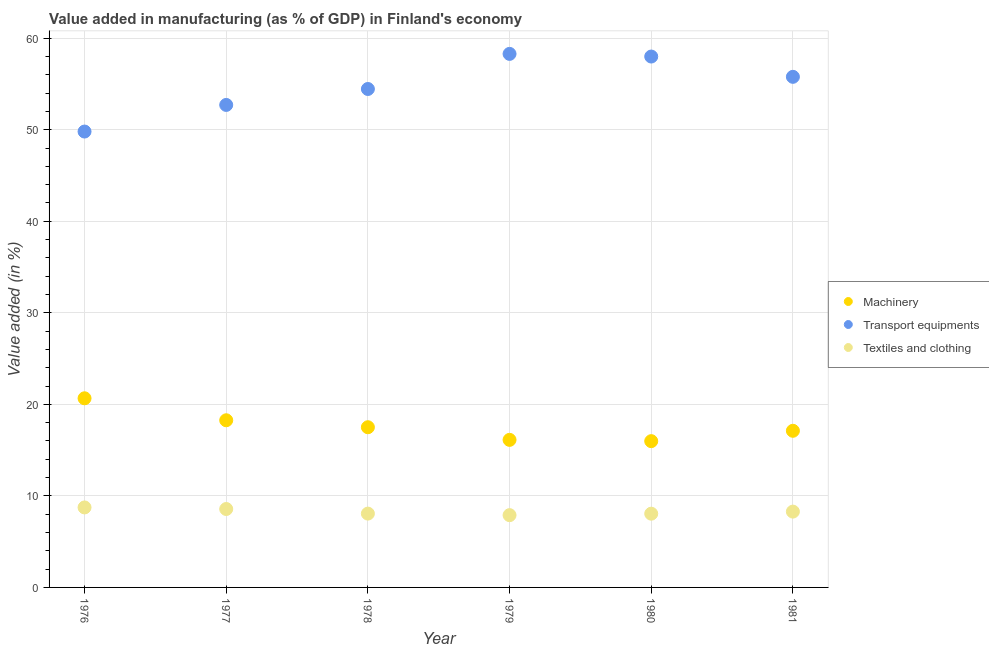How many different coloured dotlines are there?
Keep it short and to the point. 3. What is the value added in manufacturing machinery in 1979?
Your answer should be very brief. 16.12. Across all years, what is the maximum value added in manufacturing transport equipments?
Offer a very short reply. 58.29. Across all years, what is the minimum value added in manufacturing machinery?
Offer a very short reply. 15.98. In which year was the value added in manufacturing textile and clothing maximum?
Provide a succinct answer. 1976. In which year was the value added in manufacturing textile and clothing minimum?
Ensure brevity in your answer.  1979. What is the total value added in manufacturing textile and clothing in the graph?
Give a very brief answer. 49.61. What is the difference between the value added in manufacturing machinery in 1980 and that in 1981?
Keep it short and to the point. -1.13. What is the difference between the value added in manufacturing machinery in 1981 and the value added in manufacturing transport equipments in 1980?
Make the answer very short. -40.89. What is the average value added in manufacturing machinery per year?
Keep it short and to the point. 17.61. In the year 1978, what is the difference between the value added in manufacturing transport equipments and value added in manufacturing machinery?
Your answer should be very brief. 36.95. What is the ratio of the value added in manufacturing transport equipments in 1978 to that in 1979?
Provide a succinct answer. 0.93. What is the difference between the highest and the second highest value added in manufacturing machinery?
Your answer should be very brief. 2.4. What is the difference between the highest and the lowest value added in manufacturing textile and clothing?
Offer a terse response. 0.84. In how many years, is the value added in manufacturing transport equipments greater than the average value added in manufacturing transport equipments taken over all years?
Offer a very short reply. 3. Is the sum of the value added in manufacturing machinery in 1977 and 1980 greater than the maximum value added in manufacturing transport equipments across all years?
Provide a short and direct response. No. Is it the case that in every year, the sum of the value added in manufacturing machinery and value added in manufacturing transport equipments is greater than the value added in manufacturing textile and clothing?
Provide a succinct answer. Yes. Is the value added in manufacturing machinery strictly less than the value added in manufacturing transport equipments over the years?
Provide a succinct answer. Yes. How many legend labels are there?
Provide a succinct answer. 3. How are the legend labels stacked?
Provide a short and direct response. Vertical. What is the title of the graph?
Your answer should be compact. Value added in manufacturing (as % of GDP) in Finland's economy. Does "Spain" appear as one of the legend labels in the graph?
Make the answer very short. No. What is the label or title of the Y-axis?
Your response must be concise. Value added (in %). What is the Value added (in %) of Machinery in 1976?
Your response must be concise. 20.66. What is the Value added (in %) in Transport equipments in 1976?
Offer a terse response. 49.81. What is the Value added (in %) of Textiles and clothing in 1976?
Your answer should be very brief. 8.74. What is the Value added (in %) in Machinery in 1977?
Offer a terse response. 18.26. What is the Value added (in %) of Transport equipments in 1977?
Your answer should be very brief. 52.71. What is the Value added (in %) of Textiles and clothing in 1977?
Offer a very short reply. 8.57. What is the Value added (in %) of Machinery in 1978?
Give a very brief answer. 17.5. What is the Value added (in %) of Transport equipments in 1978?
Make the answer very short. 54.45. What is the Value added (in %) of Textiles and clothing in 1978?
Your answer should be very brief. 8.07. What is the Value added (in %) of Machinery in 1979?
Your answer should be compact. 16.12. What is the Value added (in %) in Transport equipments in 1979?
Keep it short and to the point. 58.29. What is the Value added (in %) of Textiles and clothing in 1979?
Offer a very short reply. 7.9. What is the Value added (in %) in Machinery in 1980?
Provide a succinct answer. 15.98. What is the Value added (in %) in Transport equipments in 1980?
Provide a short and direct response. 58. What is the Value added (in %) in Textiles and clothing in 1980?
Make the answer very short. 8.06. What is the Value added (in %) of Machinery in 1981?
Your answer should be very brief. 17.11. What is the Value added (in %) in Transport equipments in 1981?
Keep it short and to the point. 55.78. What is the Value added (in %) in Textiles and clothing in 1981?
Make the answer very short. 8.28. Across all years, what is the maximum Value added (in %) of Machinery?
Keep it short and to the point. 20.66. Across all years, what is the maximum Value added (in %) in Transport equipments?
Your answer should be compact. 58.29. Across all years, what is the maximum Value added (in %) in Textiles and clothing?
Offer a very short reply. 8.74. Across all years, what is the minimum Value added (in %) of Machinery?
Offer a very short reply. 15.98. Across all years, what is the minimum Value added (in %) in Transport equipments?
Give a very brief answer. 49.81. Across all years, what is the minimum Value added (in %) in Textiles and clothing?
Keep it short and to the point. 7.9. What is the total Value added (in %) in Machinery in the graph?
Your answer should be very brief. 105.64. What is the total Value added (in %) in Transport equipments in the graph?
Your answer should be compact. 329.05. What is the total Value added (in %) in Textiles and clothing in the graph?
Your response must be concise. 49.61. What is the difference between the Value added (in %) of Machinery in 1976 and that in 1977?
Ensure brevity in your answer.  2.4. What is the difference between the Value added (in %) in Transport equipments in 1976 and that in 1977?
Offer a very short reply. -2.91. What is the difference between the Value added (in %) in Textiles and clothing in 1976 and that in 1977?
Make the answer very short. 0.17. What is the difference between the Value added (in %) in Machinery in 1976 and that in 1978?
Offer a very short reply. 3.16. What is the difference between the Value added (in %) in Transport equipments in 1976 and that in 1978?
Your response must be concise. -4.65. What is the difference between the Value added (in %) in Textiles and clothing in 1976 and that in 1978?
Provide a succinct answer. 0.67. What is the difference between the Value added (in %) of Machinery in 1976 and that in 1979?
Your answer should be compact. 4.54. What is the difference between the Value added (in %) in Transport equipments in 1976 and that in 1979?
Keep it short and to the point. -8.48. What is the difference between the Value added (in %) of Textiles and clothing in 1976 and that in 1979?
Provide a short and direct response. 0.84. What is the difference between the Value added (in %) of Machinery in 1976 and that in 1980?
Keep it short and to the point. 4.68. What is the difference between the Value added (in %) in Transport equipments in 1976 and that in 1980?
Provide a succinct answer. -8.19. What is the difference between the Value added (in %) of Textiles and clothing in 1976 and that in 1980?
Keep it short and to the point. 0.68. What is the difference between the Value added (in %) of Machinery in 1976 and that in 1981?
Your answer should be compact. 3.55. What is the difference between the Value added (in %) in Transport equipments in 1976 and that in 1981?
Your response must be concise. -5.98. What is the difference between the Value added (in %) in Textiles and clothing in 1976 and that in 1981?
Offer a very short reply. 0.46. What is the difference between the Value added (in %) of Machinery in 1977 and that in 1978?
Give a very brief answer. 0.76. What is the difference between the Value added (in %) of Transport equipments in 1977 and that in 1978?
Your answer should be very brief. -1.74. What is the difference between the Value added (in %) in Textiles and clothing in 1977 and that in 1978?
Your answer should be compact. 0.5. What is the difference between the Value added (in %) of Machinery in 1977 and that in 1979?
Ensure brevity in your answer.  2.14. What is the difference between the Value added (in %) of Transport equipments in 1977 and that in 1979?
Ensure brevity in your answer.  -5.58. What is the difference between the Value added (in %) of Textiles and clothing in 1977 and that in 1979?
Offer a terse response. 0.67. What is the difference between the Value added (in %) of Machinery in 1977 and that in 1980?
Your answer should be very brief. 2.28. What is the difference between the Value added (in %) of Transport equipments in 1977 and that in 1980?
Your response must be concise. -5.29. What is the difference between the Value added (in %) of Textiles and clothing in 1977 and that in 1980?
Provide a short and direct response. 0.51. What is the difference between the Value added (in %) in Machinery in 1977 and that in 1981?
Keep it short and to the point. 1.15. What is the difference between the Value added (in %) in Transport equipments in 1977 and that in 1981?
Offer a terse response. -3.07. What is the difference between the Value added (in %) in Textiles and clothing in 1977 and that in 1981?
Your answer should be very brief. 0.28. What is the difference between the Value added (in %) in Machinery in 1978 and that in 1979?
Provide a succinct answer. 1.38. What is the difference between the Value added (in %) of Transport equipments in 1978 and that in 1979?
Make the answer very short. -3.84. What is the difference between the Value added (in %) in Textiles and clothing in 1978 and that in 1979?
Provide a short and direct response. 0.17. What is the difference between the Value added (in %) in Machinery in 1978 and that in 1980?
Give a very brief answer. 1.52. What is the difference between the Value added (in %) of Transport equipments in 1978 and that in 1980?
Keep it short and to the point. -3.55. What is the difference between the Value added (in %) in Textiles and clothing in 1978 and that in 1980?
Your answer should be very brief. 0.01. What is the difference between the Value added (in %) of Machinery in 1978 and that in 1981?
Your answer should be compact. 0.39. What is the difference between the Value added (in %) in Transport equipments in 1978 and that in 1981?
Make the answer very short. -1.33. What is the difference between the Value added (in %) in Textiles and clothing in 1978 and that in 1981?
Your response must be concise. -0.22. What is the difference between the Value added (in %) of Machinery in 1979 and that in 1980?
Ensure brevity in your answer.  0.14. What is the difference between the Value added (in %) of Transport equipments in 1979 and that in 1980?
Offer a very short reply. 0.29. What is the difference between the Value added (in %) in Textiles and clothing in 1979 and that in 1980?
Ensure brevity in your answer.  -0.16. What is the difference between the Value added (in %) in Machinery in 1979 and that in 1981?
Offer a terse response. -0.99. What is the difference between the Value added (in %) in Transport equipments in 1979 and that in 1981?
Your answer should be very brief. 2.51. What is the difference between the Value added (in %) of Textiles and clothing in 1979 and that in 1981?
Your answer should be very brief. -0.39. What is the difference between the Value added (in %) in Machinery in 1980 and that in 1981?
Give a very brief answer. -1.13. What is the difference between the Value added (in %) in Transport equipments in 1980 and that in 1981?
Ensure brevity in your answer.  2.22. What is the difference between the Value added (in %) in Textiles and clothing in 1980 and that in 1981?
Make the answer very short. -0.23. What is the difference between the Value added (in %) of Machinery in 1976 and the Value added (in %) of Transport equipments in 1977?
Provide a short and direct response. -32.05. What is the difference between the Value added (in %) of Machinery in 1976 and the Value added (in %) of Textiles and clothing in 1977?
Ensure brevity in your answer.  12.1. What is the difference between the Value added (in %) in Transport equipments in 1976 and the Value added (in %) in Textiles and clothing in 1977?
Offer a terse response. 41.24. What is the difference between the Value added (in %) in Machinery in 1976 and the Value added (in %) in Transport equipments in 1978?
Offer a very short reply. -33.79. What is the difference between the Value added (in %) in Machinery in 1976 and the Value added (in %) in Textiles and clothing in 1978?
Your answer should be compact. 12.6. What is the difference between the Value added (in %) in Transport equipments in 1976 and the Value added (in %) in Textiles and clothing in 1978?
Ensure brevity in your answer.  41.74. What is the difference between the Value added (in %) in Machinery in 1976 and the Value added (in %) in Transport equipments in 1979?
Give a very brief answer. -37.63. What is the difference between the Value added (in %) of Machinery in 1976 and the Value added (in %) of Textiles and clothing in 1979?
Your answer should be compact. 12.77. What is the difference between the Value added (in %) of Transport equipments in 1976 and the Value added (in %) of Textiles and clothing in 1979?
Provide a short and direct response. 41.91. What is the difference between the Value added (in %) in Machinery in 1976 and the Value added (in %) in Transport equipments in 1980?
Your response must be concise. -37.34. What is the difference between the Value added (in %) of Machinery in 1976 and the Value added (in %) of Textiles and clothing in 1980?
Your answer should be compact. 12.61. What is the difference between the Value added (in %) in Transport equipments in 1976 and the Value added (in %) in Textiles and clothing in 1980?
Keep it short and to the point. 41.75. What is the difference between the Value added (in %) in Machinery in 1976 and the Value added (in %) in Transport equipments in 1981?
Your answer should be very brief. -35.12. What is the difference between the Value added (in %) of Machinery in 1976 and the Value added (in %) of Textiles and clothing in 1981?
Give a very brief answer. 12.38. What is the difference between the Value added (in %) in Transport equipments in 1976 and the Value added (in %) in Textiles and clothing in 1981?
Offer a very short reply. 41.52. What is the difference between the Value added (in %) in Machinery in 1977 and the Value added (in %) in Transport equipments in 1978?
Your answer should be compact. -36.19. What is the difference between the Value added (in %) in Machinery in 1977 and the Value added (in %) in Textiles and clothing in 1978?
Provide a succinct answer. 10.2. What is the difference between the Value added (in %) in Transport equipments in 1977 and the Value added (in %) in Textiles and clothing in 1978?
Keep it short and to the point. 44.65. What is the difference between the Value added (in %) in Machinery in 1977 and the Value added (in %) in Transport equipments in 1979?
Offer a terse response. -40.03. What is the difference between the Value added (in %) of Machinery in 1977 and the Value added (in %) of Textiles and clothing in 1979?
Ensure brevity in your answer.  10.37. What is the difference between the Value added (in %) in Transport equipments in 1977 and the Value added (in %) in Textiles and clothing in 1979?
Provide a short and direct response. 44.82. What is the difference between the Value added (in %) of Machinery in 1977 and the Value added (in %) of Transport equipments in 1980?
Provide a short and direct response. -39.74. What is the difference between the Value added (in %) in Machinery in 1977 and the Value added (in %) in Textiles and clothing in 1980?
Provide a short and direct response. 10.21. What is the difference between the Value added (in %) of Transport equipments in 1977 and the Value added (in %) of Textiles and clothing in 1980?
Ensure brevity in your answer.  44.66. What is the difference between the Value added (in %) in Machinery in 1977 and the Value added (in %) in Transport equipments in 1981?
Offer a very short reply. -37.52. What is the difference between the Value added (in %) of Machinery in 1977 and the Value added (in %) of Textiles and clothing in 1981?
Your answer should be very brief. 9.98. What is the difference between the Value added (in %) in Transport equipments in 1977 and the Value added (in %) in Textiles and clothing in 1981?
Your answer should be compact. 44.43. What is the difference between the Value added (in %) in Machinery in 1978 and the Value added (in %) in Transport equipments in 1979?
Provide a succinct answer. -40.79. What is the difference between the Value added (in %) of Machinery in 1978 and the Value added (in %) of Textiles and clothing in 1979?
Make the answer very short. 9.6. What is the difference between the Value added (in %) of Transport equipments in 1978 and the Value added (in %) of Textiles and clothing in 1979?
Ensure brevity in your answer.  46.56. What is the difference between the Value added (in %) in Machinery in 1978 and the Value added (in %) in Transport equipments in 1980?
Offer a terse response. -40.5. What is the difference between the Value added (in %) in Machinery in 1978 and the Value added (in %) in Textiles and clothing in 1980?
Make the answer very short. 9.45. What is the difference between the Value added (in %) of Transport equipments in 1978 and the Value added (in %) of Textiles and clothing in 1980?
Make the answer very short. 46.4. What is the difference between the Value added (in %) of Machinery in 1978 and the Value added (in %) of Transport equipments in 1981?
Ensure brevity in your answer.  -38.28. What is the difference between the Value added (in %) of Machinery in 1978 and the Value added (in %) of Textiles and clothing in 1981?
Offer a terse response. 9.22. What is the difference between the Value added (in %) of Transport equipments in 1978 and the Value added (in %) of Textiles and clothing in 1981?
Make the answer very short. 46.17. What is the difference between the Value added (in %) in Machinery in 1979 and the Value added (in %) in Transport equipments in 1980?
Provide a short and direct response. -41.88. What is the difference between the Value added (in %) of Machinery in 1979 and the Value added (in %) of Textiles and clothing in 1980?
Offer a terse response. 8.07. What is the difference between the Value added (in %) of Transport equipments in 1979 and the Value added (in %) of Textiles and clothing in 1980?
Provide a succinct answer. 50.23. What is the difference between the Value added (in %) in Machinery in 1979 and the Value added (in %) in Transport equipments in 1981?
Offer a very short reply. -39.66. What is the difference between the Value added (in %) in Machinery in 1979 and the Value added (in %) in Textiles and clothing in 1981?
Make the answer very short. 7.84. What is the difference between the Value added (in %) in Transport equipments in 1979 and the Value added (in %) in Textiles and clothing in 1981?
Give a very brief answer. 50.01. What is the difference between the Value added (in %) of Machinery in 1980 and the Value added (in %) of Transport equipments in 1981?
Offer a very short reply. -39.8. What is the difference between the Value added (in %) in Machinery in 1980 and the Value added (in %) in Textiles and clothing in 1981?
Your answer should be compact. 7.7. What is the difference between the Value added (in %) of Transport equipments in 1980 and the Value added (in %) of Textiles and clothing in 1981?
Offer a very short reply. 49.72. What is the average Value added (in %) of Machinery per year?
Make the answer very short. 17.61. What is the average Value added (in %) in Transport equipments per year?
Your response must be concise. 54.84. What is the average Value added (in %) in Textiles and clothing per year?
Make the answer very short. 8.27. In the year 1976, what is the difference between the Value added (in %) of Machinery and Value added (in %) of Transport equipments?
Your answer should be very brief. -29.14. In the year 1976, what is the difference between the Value added (in %) of Machinery and Value added (in %) of Textiles and clothing?
Ensure brevity in your answer.  11.92. In the year 1976, what is the difference between the Value added (in %) of Transport equipments and Value added (in %) of Textiles and clothing?
Provide a short and direct response. 41.07. In the year 1977, what is the difference between the Value added (in %) of Machinery and Value added (in %) of Transport equipments?
Your response must be concise. -34.45. In the year 1977, what is the difference between the Value added (in %) of Machinery and Value added (in %) of Textiles and clothing?
Your answer should be compact. 9.7. In the year 1977, what is the difference between the Value added (in %) in Transport equipments and Value added (in %) in Textiles and clothing?
Keep it short and to the point. 44.15. In the year 1978, what is the difference between the Value added (in %) in Machinery and Value added (in %) in Transport equipments?
Provide a succinct answer. -36.95. In the year 1978, what is the difference between the Value added (in %) in Machinery and Value added (in %) in Textiles and clothing?
Your answer should be compact. 9.44. In the year 1978, what is the difference between the Value added (in %) of Transport equipments and Value added (in %) of Textiles and clothing?
Make the answer very short. 46.39. In the year 1979, what is the difference between the Value added (in %) in Machinery and Value added (in %) in Transport equipments?
Offer a terse response. -42.17. In the year 1979, what is the difference between the Value added (in %) of Machinery and Value added (in %) of Textiles and clothing?
Offer a terse response. 8.22. In the year 1979, what is the difference between the Value added (in %) in Transport equipments and Value added (in %) in Textiles and clothing?
Ensure brevity in your answer.  50.39. In the year 1980, what is the difference between the Value added (in %) in Machinery and Value added (in %) in Transport equipments?
Offer a terse response. -42.02. In the year 1980, what is the difference between the Value added (in %) in Machinery and Value added (in %) in Textiles and clothing?
Give a very brief answer. 7.93. In the year 1980, what is the difference between the Value added (in %) in Transport equipments and Value added (in %) in Textiles and clothing?
Keep it short and to the point. 49.94. In the year 1981, what is the difference between the Value added (in %) of Machinery and Value added (in %) of Transport equipments?
Provide a succinct answer. -38.67. In the year 1981, what is the difference between the Value added (in %) of Machinery and Value added (in %) of Textiles and clothing?
Keep it short and to the point. 8.83. In the year 1981, what is the difference between the Value added (in %) of Transport equipments and Value added (in %) of Textiles and clothing?
Make the answer very short. 47.5. What is the ratio of the Value added (in %) in Machinery in 1976 to that in 1977?
Your answer should be very brief. 1.13. What is the ratio of the Value added (in %) of Transport equipments in 1976 to that in 1977?
Your response must be concise. 0.94. What is the ratio of the Value added (in %) of Textiles and clothing in 1976 to that in 1977?
Your answer should be compact. 1.02. What is the ratio of the Value added (in %) of Machinery in 1976 to that in 1978?
Offer a terse response. 1.18. What is the ratio of the Value added (in %) in Transport equipments in 1976 to that in 1978?
Offer a very short reply. 0.91. What is the ratio of the Value added (in %) in Textiles and clothing in 1976 to that in 1978?
Offer a very short reply. 1.08. What is the ratio of the Value added (in %) of Machinery in 1976 to that in 1979?
Make the answer very short. 1.28. What is the ratio of the Value added (in %) of Transport equipments in 1976 to that in 1979?
Keep it short and to the point. 0.85. What is the ratio of the Value added (in %) of Textiles and clothing in 1976 to that in 1979?
Give a very brief answer. 1.11. What is the ratio of the Value added (in %) in Machinery in 1976 to that in 1980?
Provide a succinct answer. 1.29. What is the ratio of the Value added (in %) in Transport equipments in 1976 to that in 1980?
Provide a succinct answer. 0.86. What is the ratio of the Value added (in %) in Textiles and clothing in 1976 to that in 1980?
Ensure brevity in your answer.  1.08. What is the ratio of the Value added (in %) of Machinery in 1976 to that in 1981?
Provide a succinct answer. 1.21. What is the ratio of the Value added (in %) in Transport equipments in 1976 to that in 1981?
Offer a very short reply. 0.89. What is the ratio of the Value added (in %) in Textiles and clothing in 1976 to that in 1981?
Your answer should be very brief. 1.06. What is the ratio of the Value added (in %) in Machinery in 1977 to that in 1978?
Ensure brevity in your answer.  1.04. What is the ratio of the Value added (in %) in Textiles and clothing in 1977 to that in 1978?
Offer a very short reply. 1.06. What is the ratio of the Value added (in %) of Machinery in 1977 to that in 1979?
Ensure brevity in your answer.  1.13. What is the ratio of the Value added (in %) in Transport equipments in 1977 to that in 1979?
Make the answer very short. 0.9. What is the ratio of the Value added (in %) of Textiles and clothing in 1977 to that in 1979?
Provide a short and direct response. 1.08. What is the ratio of the Value added (in %) of Machinery in 1977 to that in 1980?
Your response must be concise. 1.14. What is the ratio of the Value added (in %) in Transport equipments in 1977 to that in 1980?
Keep it short and to the point. 0.91. What is the ratio of the Value added (in %) in Textiles and clothing in 1977 to that in 1980?
Give a very brief answer. 1.06. What is the ratio of the Value added (in %) of Machinery in 1977 to that in 1981?
Your response must be concise. 1.07. What is the ratio of the Value added (in %) in Transport equipments in 1977 to that in 1981?
Offer a terse response. 0.94. What is the ratio of the Value added (in %) in Textiles and clothing in 1977 to that in 1981?
Give a very brief answer. 1.03. What is the ratio of the Value added (in %) in Machinery in 1978 to that in 1979?
Offer a very short reply. 1.09. What is the ratio of the Value added (in %) in Transport equipments in 1978 to that in 1979?
Your answer should be compact. 0.93. What is the ratio of the Value added (in %) of Textiles and clothing in 1978 to that in 1979?
Provide a short and direct response. 1.02. What is the ratio of the Value added (in %) in Machinery in 1978 to that in 1980?
Offer a very short reply. 1.1. What is the ratio of the Value added (in %) in Transport equipments in 1978 to that in 1980?
Offer a terse response. 0.94. What is the ratio of the Value added (in %) in Machinery in 1978 to that in 1981?
Give a very brief answer. 1.02. What is the ratio of the Value added (in %) of Transport equipments in 1978 to that in 1981?
Your response must be concise. 0.98. What is the ratio of the Value added (in %) of Textiles and clothing in 1978 to that in 1981?
Offer a very short reply. 0.97. What is the ratio of the Value added (in %) of Machinery in 1979 to that in 1980?
Offer a very short reply. 1.01. What is the ratio of the Value added (in %) of Transport equipments in 1979 to that in 1980?
Ensure brevity in your answer.  1. What is the ratio of the Value added (in %) in Textiles and clothing in 1979 to that in 1980?
Make the answer very short. 0.98. What is the ratio of the Value added (in %) in Machinery in 1979 to that in 1981?
Offer a very short reply. 0.94. What is the ratio of the Value added (in %) in Transport equipments in 1979 to that in 1981?
Give a very brief answer. 1.04. What is the ratio of the Value added (in %) in Textiles and clothing in 1979 to that in 1981?
Keep it short and to the point. 0.95. What is the ratio of the Value added (in %) of Machinery in 1980 to that in 1981?
Make the answer very short. 0.93. What is the ratio of the Value added (in %) in Transport equipments in 1980 to that in 1981?
Offer a very short reply. 1.04. What is the ratio of the Value added (in %) of Textiles and clothing in 1980 to that in 1981?
Make the answer very short. 0.97. What is the difference between the highest and the second highest Value added (in %) in Machinery?
Ensure brevity in your answer.  2.4. What is the difference between the highest and the second highest Value added (in %) in Transport equipments?
Offer a terse response. 0.29. What is the difference between the highest and the second highest Value added (in %) of Textiles and clothing?
Provide a short and direct response. 0.17. What is the difference between the highest and the lowest Value added (in %) of Machinery?
Offer a terse response. 4.68. What is the difference between the highest and the lowest Value added (in %) of Transport equipments?
Give a very brief answer. 8.48. What is the difference between the highest and the lowest Value added (in %) of Textiles and clothing?
Your answer should be compact. 0.84. 